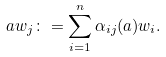Convert formula to latex. <formula><loc_0><loc_0><loc_500><loc_500>a w _ { j } \colon = \sum _ { i = 1 } ^ { n } \alpha _ { i j } ( a ) w _ { i } .</formula> 